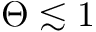Convert formula to latex. <formula><loc_0><loc_0><loc_500><loc_500>\Theta \lesssim 1</formula> 